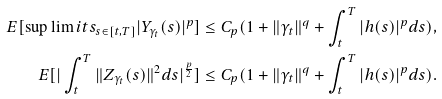Convert formula to latex. <formula><loc_0><loc_0><loc_500><loc_500>E [ \sup \lim i t s _ { s \in [ t , T ] } | Y _ { { \gamma _ { t } } } ( s ) | ^ { p } ] & \leq C _ { p } ( 1 + \| \gamma _ { t } \| ^ { q } + \int ^ { T } _ { t } | h ( s ) | ^ { p } d s ) , \\ E [ | \int _ { t } ^ { T } \| Z _ { { \gamma _ { t } } } ( s ) \| ^ { 2 } d s | ^ { \frac { p } { 2 } } ] & \leq C _ { p } ( 1 + \| \gamma _ { t } \| ^ { q } + \int ^ { T } _ { t } | h ( s ) | ^ { p } d s ) .</formula> 